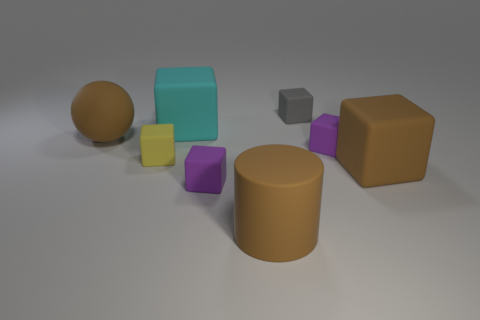Subtract all gray cubes. How many cubes are left? 5 Subtract all big rubber blocks. How many blocks are left? 4 Subtract all gray cubes. Subtract all purple cylinders. How many cubes are left? 5 Add 1 big gray metallic cubes. How many objects exist? 9 Subtract all blocks. How many objects are left? 2 Add 7 purple things. How many purple things are left? 9 Add 4 brown balls. How many brown balls exist? 5 Subtract 0 green cylinders. How many objects are left? 8 Subtract all big things. Subtract all small yellow cubes. How many objects are left? 3 